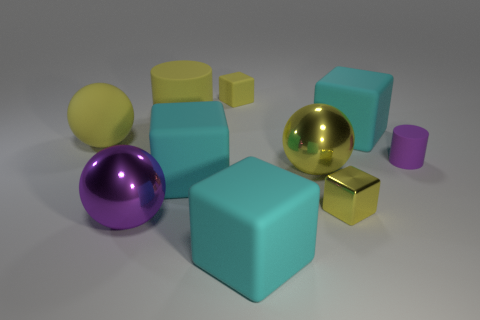What material is the small thing that is both on the left side of the small purple object and behind the tiny yellow metal thing?
Keep it short and to the point. Rubber. Does the cyan matte thing that is behind the yellow rubber sphere have the same shape as the tiny yellow metal thing?
Your answer should be compact. Yes. Are there fewer red things than yellow spheres?
Make the answer very short. Yes. What number of other large balls are the same color as the large rubber ball?
Ensure brevity in your answer.  1. There is a cylinder that is the same color as the tiny metal object; what is it made of?
Your answer should be very brief. Rubber. Does the large matte sphere have the same color as the big rubber thing that is on the right side of the tiny yellow metallic cube?
Your answer should be compact. No. Are there more cylinders than large purple metal balls?
Ensure brevity in your answer.  Yes. What is the size of the other yellow thing that is the same shape as the tiny shiny object?
Offer a terse response. Small. Is the material of the yellow cylinder the same as the cyan object that is to the left of the small yellow rubber thing?
Provide a succinct answer. Yes. How many things are either matte cubes or tiny gray matte objects?
Offer a terse response. 4. 